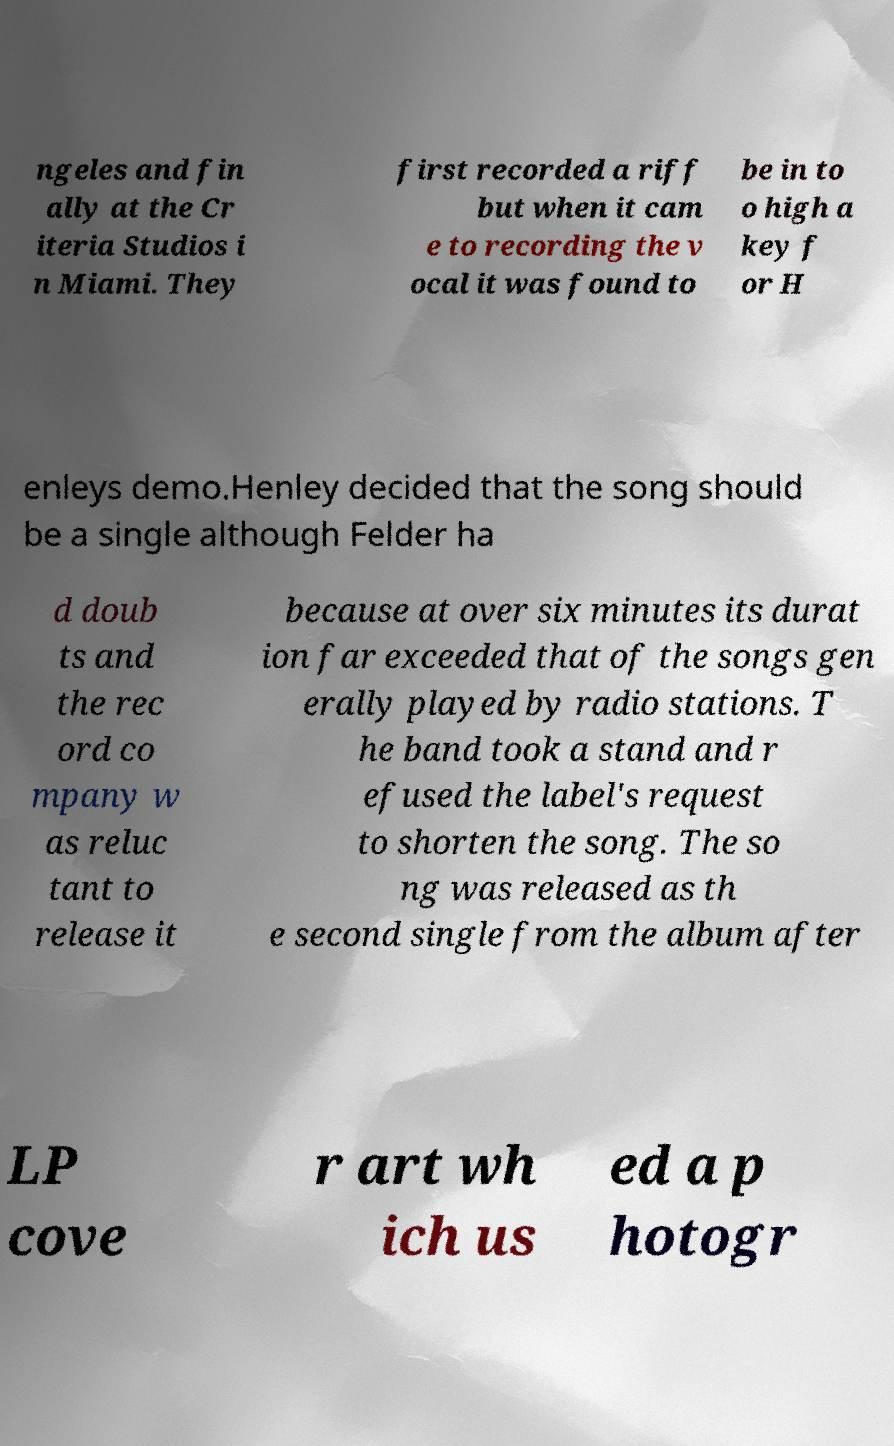I need the written content from this picture converted into text. Can you do that? ngeles and fin ally at the Cr iteria Studios i n Miami. They first recorded a riff but when it cam e to recording the v ocal it was found to be in to o high a key f or H enleys demo.Henley decided that the song should be a single although Felder ha d doub ts and the rec ord co mpany w as reluc tant to release it because at over six minutes its durat ion far exceeded that of the songs gen erally played by radio stations. T he band took a stand and r efused the label's request to shorten the song. The so ng was released as th e second single from the album after LP cove r art wh ich us ed a p hotogr 